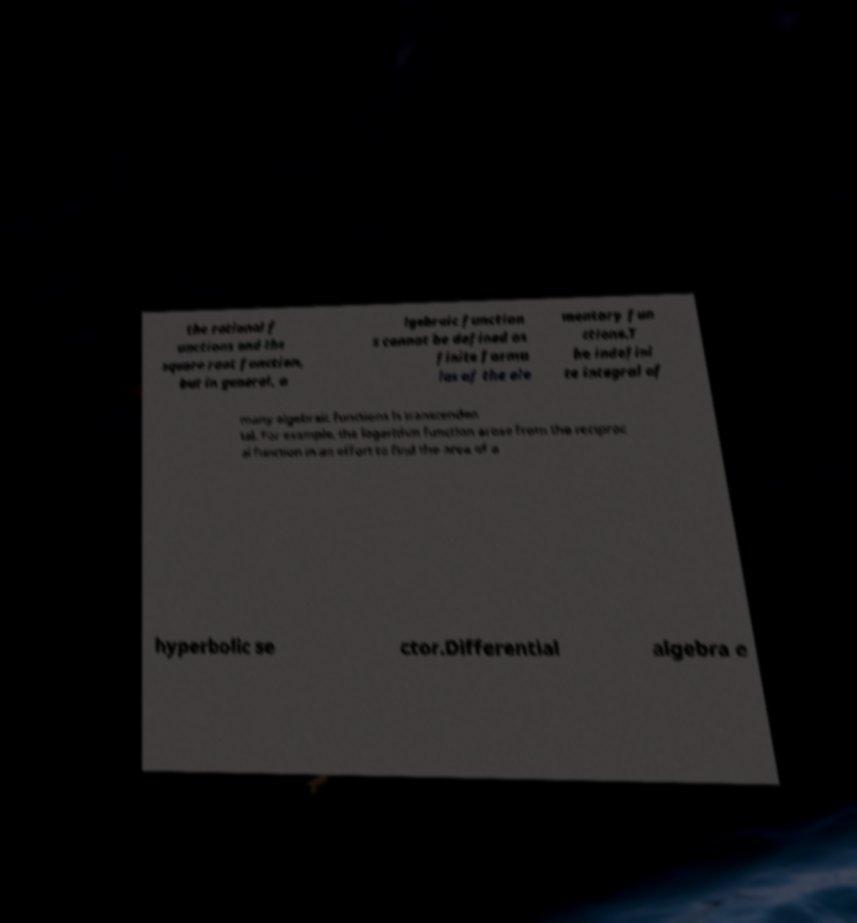Please identify and transcribe the text found in this image. the rational f unctions and the square root function, but in general, a lgebraic function s cannot be defined as finite formu las of the ele mentary fun ctions.T he indefini te integral of many algebraic functions is transcenden tal. For example, the logarithm function arose from the reciproc al function in an effort to find the area of a hyperbolic se ctor.Differential algebra e 